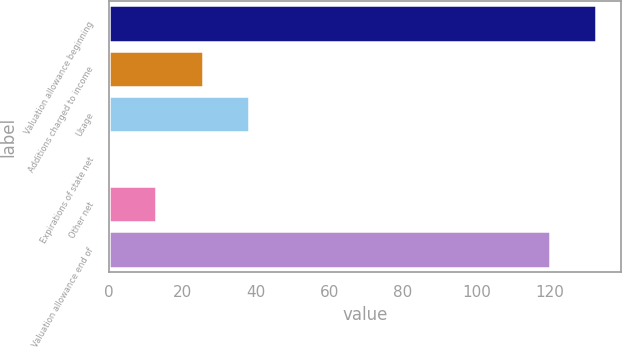Convert chart to OTSL. <chart><loc_0><loc_0><loc_500><loc_500><bar_chart><fcel>Valuation allowance beginning<fcel>Additions charged to income<fcel>Usage<fcel>Expirations of state net<fcel>Other net<fcel>Valuation allowance end of<nl><fcel>132.72<fcel>25.54<fcel>38.16<fcel>0.3<fcel>12.92<fcel>120.1<nl></chart> 